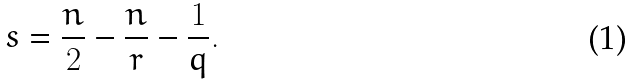<formula> <loc_0><loc_0><loc_500><loc_500>s = \frac { n } { 2 } - \frac { n } { r } - \frac { 1 } { q } .</formula> 